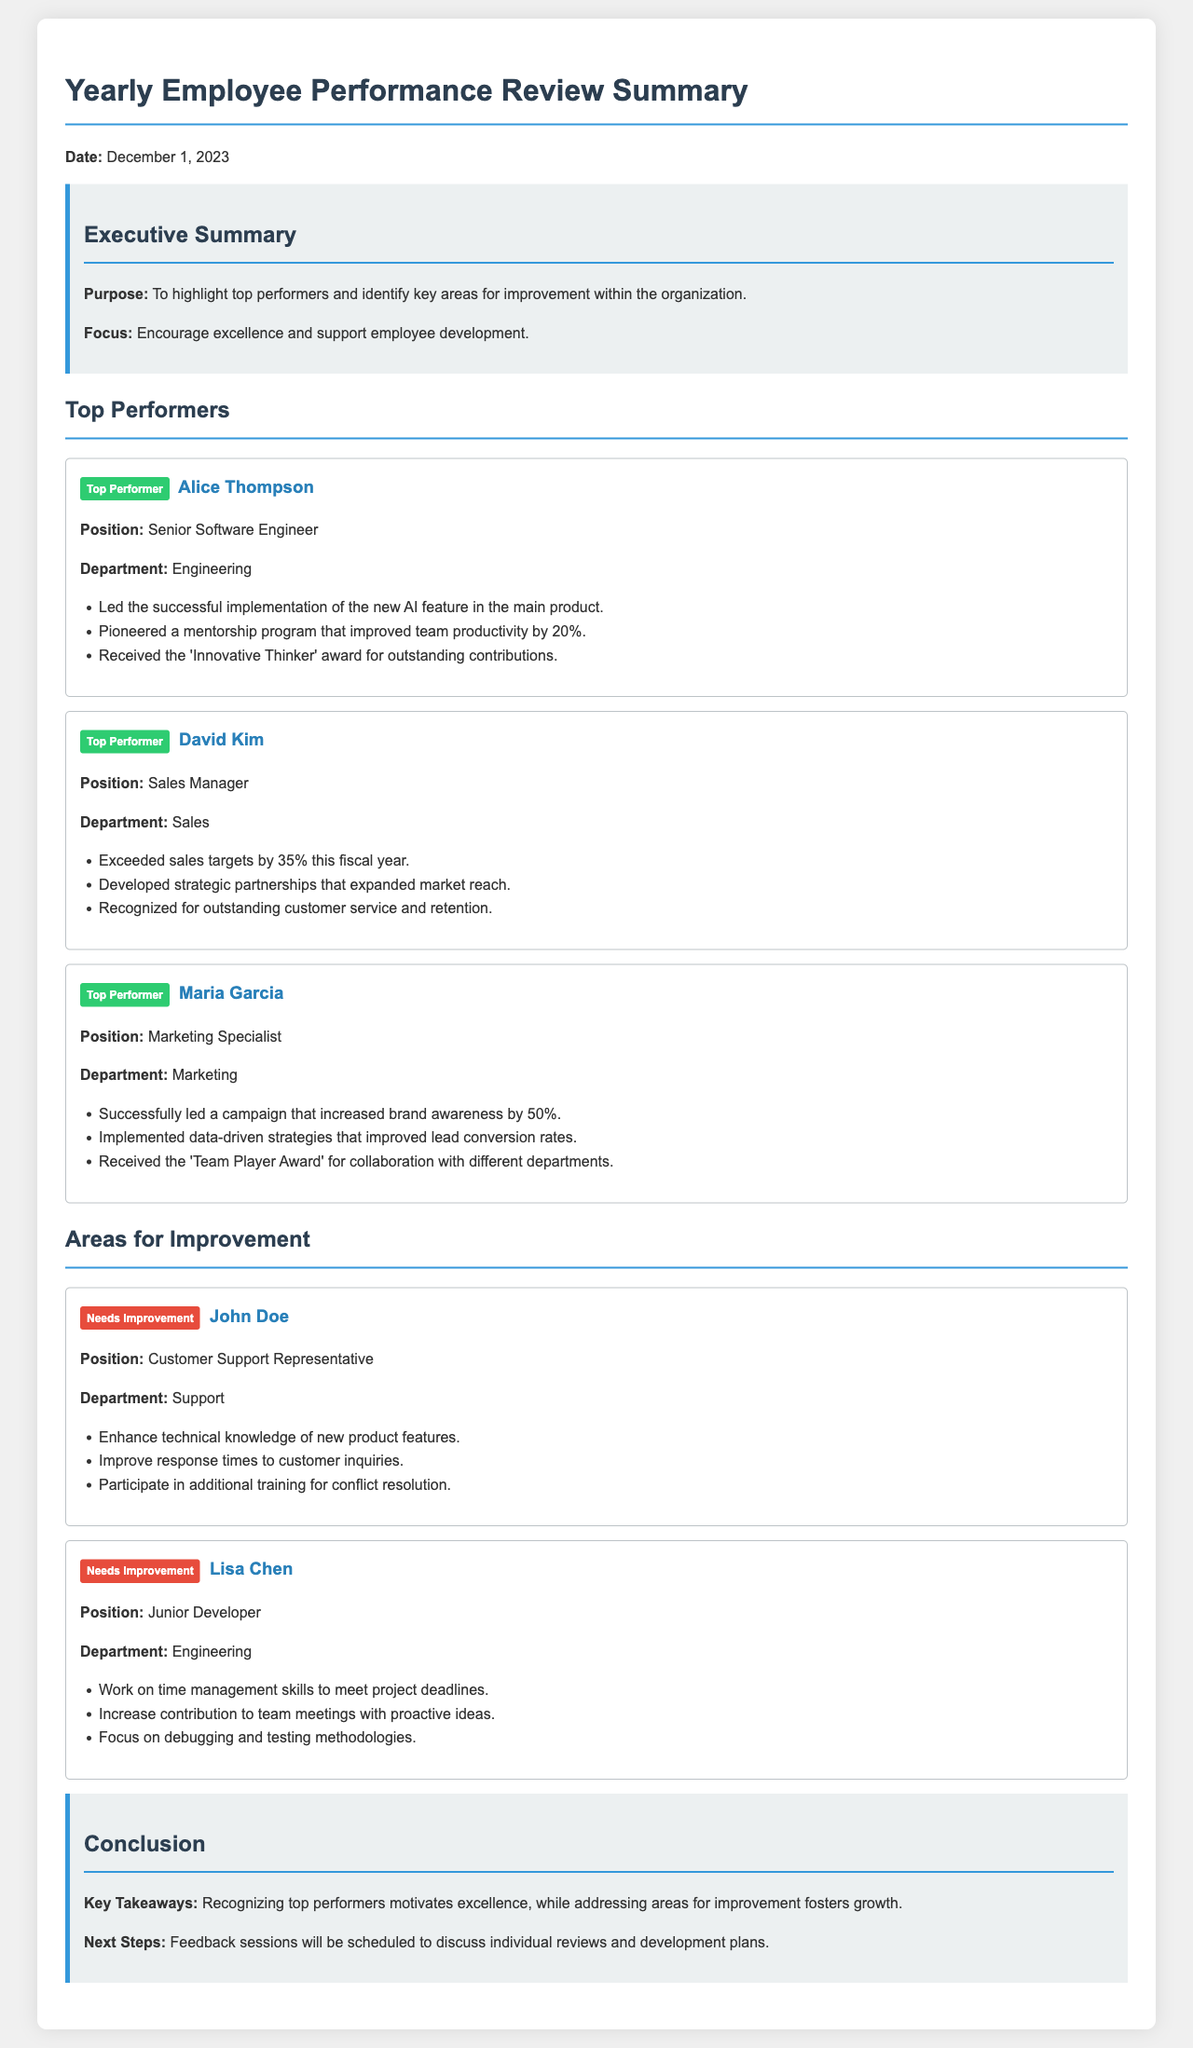What is the date of the review summary? The date is explicitly mentioned in the document as December 1, 2023.
Answer: December 1, 2023 Who is the top performer in the Engineering department? The Engineering department has Alice Thompson listed as a top performer.
Answer: Alice Thompson What percentage did David Kim exceed sales targets by? The document states he exceeded sales targets by 35%.
Answer: 35% What area needs improvement for John Doe? The document lists enhancing technical knowledge of new product features as an area for improvement for John Doe.
Answer: Enhance technical knowledge How many top performers are mentioned in the document? There are three top performers highlighted in the document: Alice Thompson, David Kim, and Maria Garcia.
Answer: Three What is the badge color for areas needing improvement? The badge color for needing improvement is explicitly mentioned as red.
Answer: Red What recognition award did Maria Garcia receive? The document states she received the 'Team Player Award' for her collaboration.
Answer: Team Player Award What is a suggested next step following the reviews? The document indicates that feedback sessions will be scheduled to discuss individual reviews and development plans.
Answer: Feedback sessions Who is the top performer in the Sales department? David Kim is the identified top performer in the Sales department.
Answer: David Kim 